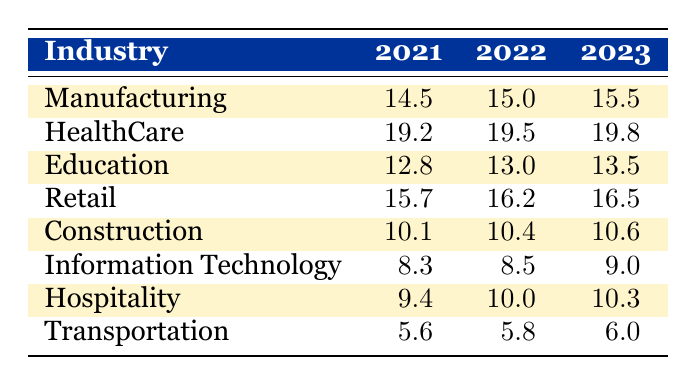What was the employment rate in the manufacturing industry in 2022? The table shows that the employment rate for the manufacturing industry in Birmingham for the year 2022 is 15.0.
Answer: 15.0 Which industry had the highest employment rate in 2023? By comparing the employment rates in 2023 across all industries, we see that the health care industry had the highest rate at 19.8.
Answer: HealthCare What is the average employment rate for the education and retail industries in 2021? The employment rate for education in 2021 is 12.8 and for retail, it is 15.7. To find the average, add these rates (12.8 + 15.7 = 28.5) and divide by 2. The average is 28.5 / 2 = 14.25.
Answer: 14.25 Did the employment rate for the hospitality industry increase in 2022 compared to 2021? The employment rate for hospitality in 2021 is 9.4 and in 2022 it's 10.0. Since 10.0 is greater than 9.4, it indicates an increase.
Answer: Yes What was the total employment rate for all industries in Birmingham for 2023? To find the total, sum the employment rates for all industries in 2023: (15.5 + 19.8 + 13.5 + 16.5 + 10.6 + 9.0 + 10.3 + 6.0) = 101.2. Thus, the total employment rate is 101.2.
Answer: 101.2 How much did the employment rate in the construction industry increase from 2021 to 2023? The employment rate in construction was 10.1 in 2021 and increased to 10.6 in 2023. To find the increase, subtract 10.1 from 10.6, resulting in an increase of 0.5.
Answer: 0.5 Is the employment rate in the transportation industry the lowest among all industries in 2023? Looking at the data for 2023, the transportation industry has an employment rate of 6.0, which is lower than all other industries listed. Thus, it is indeed the lowest.
Answer: Yes Which industries saw an employment rate increase of 0.5 or more from 2021 to 2023? By comparing the rates, manufacturing increased from 14.5 to 15.5, healthcare from 19.2 to 19.8 (0.6), education from 12.8 to 13.5, retail from 15.7 to 16.5, and construction from 10.1 to 10.6 (0.5). Only manufacturing (1.0) and healthcare (0.6) saw increases of 0.5 or more.
Answer: Manufacturing and HealthCare 